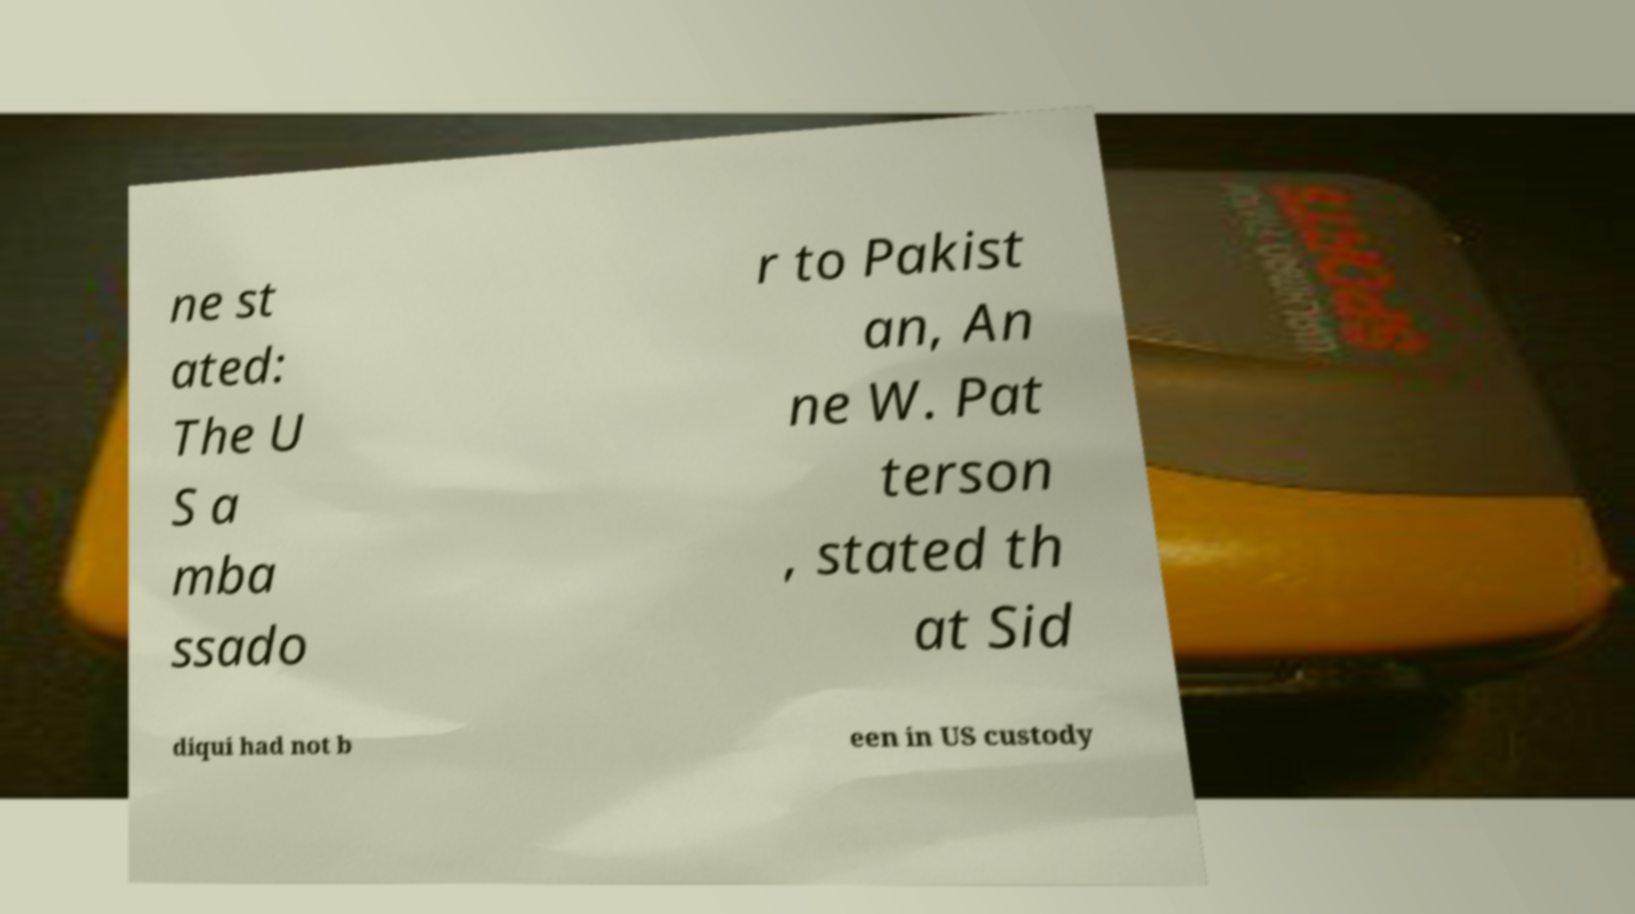For documentation purposes, I need the text within this image transcribed. Could you provide that? ne st ated: The U S a mba ssado r to Pakist an, An ne W. Pat terson , stated th at Sid diqui had not b een in US custody 